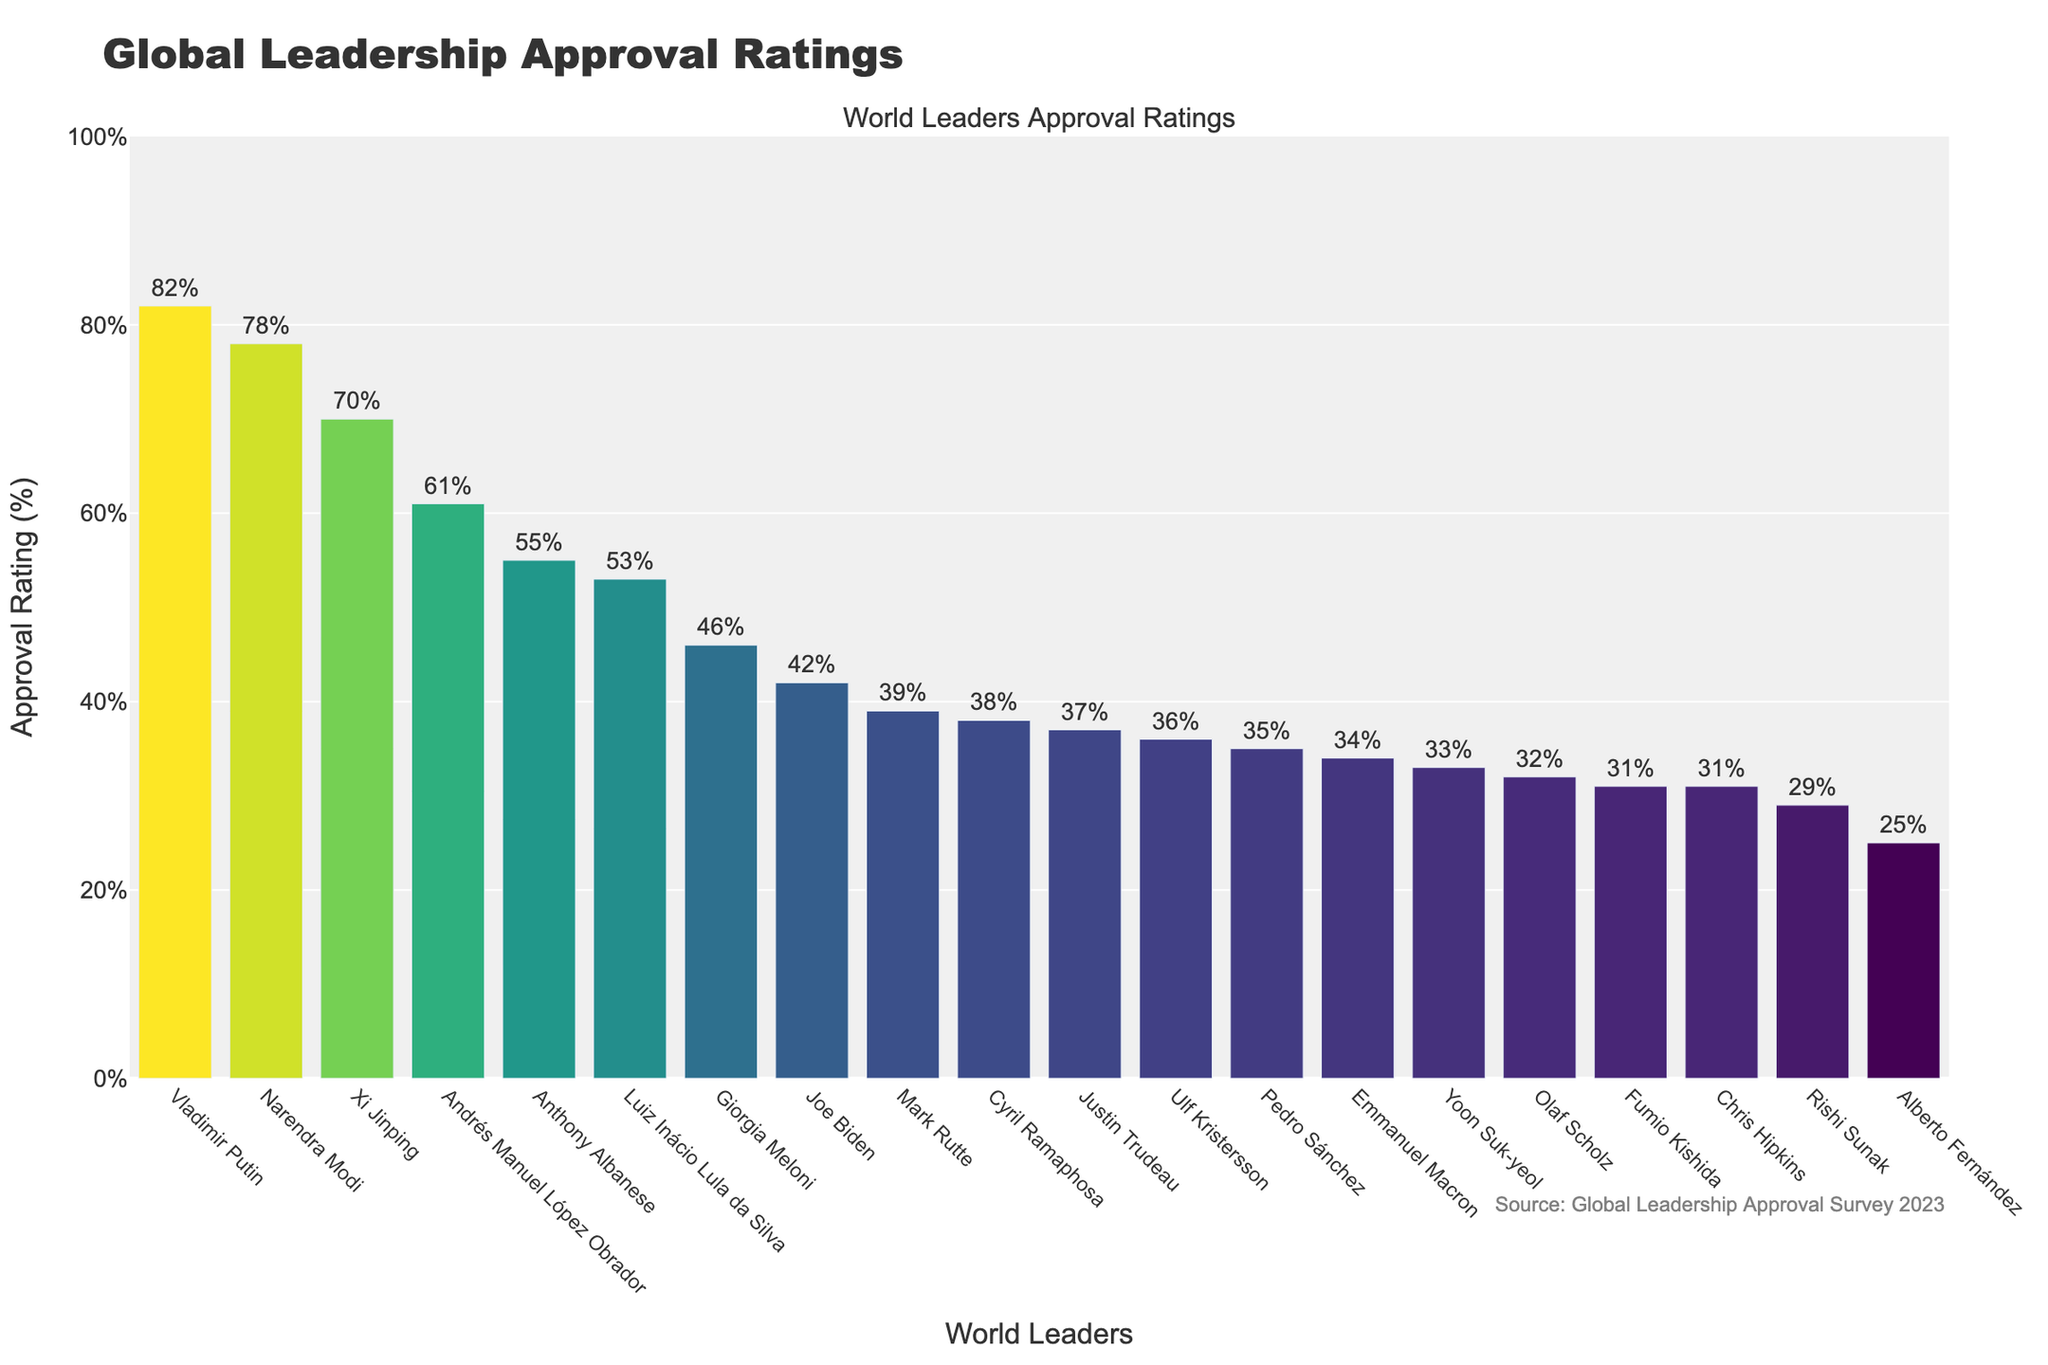Which leader has the highest approval rating? The highest approval rating can be identified by looking for the tallest bar in the chart. According to the chart, Vladimir Putin has the highest approval rating.
Answer: Vladimir Putin Which countries have leaders with approval ratings above 50%? Leaders with approval ratings above 50% are those whose bars extend above the 50% mark. Those leaders are Narendra Modi, Xi Jinping, Andrés Manuel López Obrador, Anthony Albanese, and Luiz Inácio Lula da Silva.
Answer: India, China, Mexico, Australia, Brazil What is the difference in approval rating between Joe Biden and Emmanuel Macron? Find the heights of the bars for both Joe Biden (42%) and Emmanuel Macron (34%), then subtract Macron's rating from Biden's rating (42% - 34% = 8%).
Answer: 8% Who has a higher approval rating: Giorgia Meloni or Olaf Scholz? Compare the heights of the bars for Giorgia Meloni (46%) and Olaf Scholz (32%). Giorgia Meloni’s bar is higher.
Answer: Giorgia Meloni What is the average approval rating of leaders from G7 countries (United States, United Kingdom, Germany, France, Japan, Canada, Italy)? Find the approval ratings for the G7 leaders: Joe Biden (42%), Rishi Sunak (29%), Olaf Scholz (32%), Emmanuel Macron (34%), Fumio Kishida (31%), Justin Trudeau (37%), and Giorgia Meloni (46%). Sum these ratings (42 + 29 + 32 + 34 + 31 + 37 + 46 = 251) and divide by the number of leaders (251 / 7 ≈ 35.86).
Answer: 35.86% Which leader from the list has the lowest approval rating and what is it? The lowest approval rating can be identified by looking for the shortest bar in the chart. According to the chart, Alberto Fernández has the lowest approval rating.
Answer: Alberto Fernández, 25% How many leaders have an approval rating between 30% and 40%? Count the bars whose heights fall in the range of 30% to 40%. These leaders are Olaf Scholz (32%), Emmanuel Macron (34%), Fumio Kishida (31%), Pedro Sánchez (35%), Justin Trudeau (37%), Ulf Kristersson (36%), Yoon Suk-yeol (33%), and Mark Rutte (39%). Thus, there are 8 leaders in this range.
Answer: 8 Which leader's approval rating is closest to the median value of all the leaders' approval ratings? To find the median, order all approval ratings and find the middle value. Approval ratings ordered: 25, 29, 31, 31, 32, 33, 34, 35, 36, 37, 38, 39, 42, 46, 53, 55, 61, 70, 78, 82. The median is the middle value (37 in this case). Justin Trudeau's approval rating (37%) is the median.
Answer: Justin Trudeau 